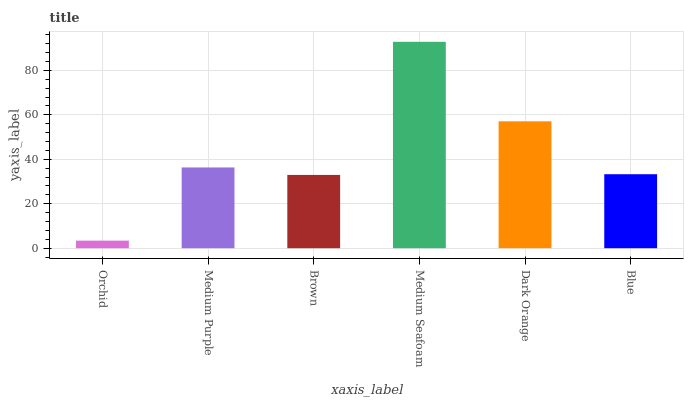Is Orchid the minimum?
Answer yes or no. Yes. Is Medium Seafoam the maximum?
Answer yes or no. Yes. Is Medium Purple the minimum?
Answer yes or no. No. Is Medium Purple the maximum?
Answer yes or no. No. Is Medium Purple greater than Orchid?
Answer yes or no. Yes. Is Orchid less than Medium Purple?
Answer yes or no. Yes. Is Orchid greater than Medium Purple?
Answer yes or no. No. Is Medium Purple less than Orchid?
Answer yes or no. No. Is Medium Purple the high median?
Answer yes or no. Yes. Is Blue the low median?
Answer yes or no. Yes. Is Orchid the high median?
Answer yes or no. No. Is Dark Orange the low median?
Answer yes or no. No. 